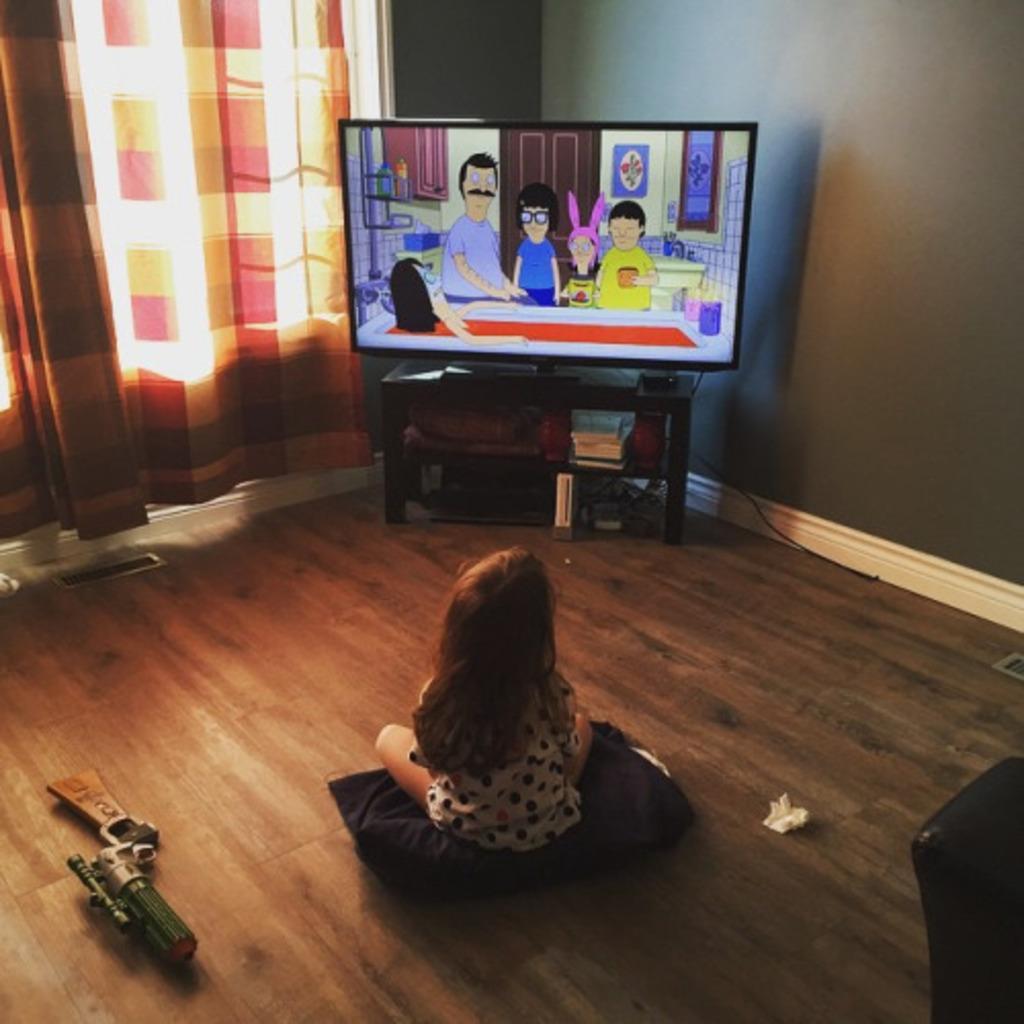Describe this image in one or two sentences. In this picture there is a television in the center of the image on a desk and there is a small girl who is sitting in the center of the image, on a pillow she is watching the television, there is a toy gun on the left side of the image and there is a window with curtain on the left side of the image. 